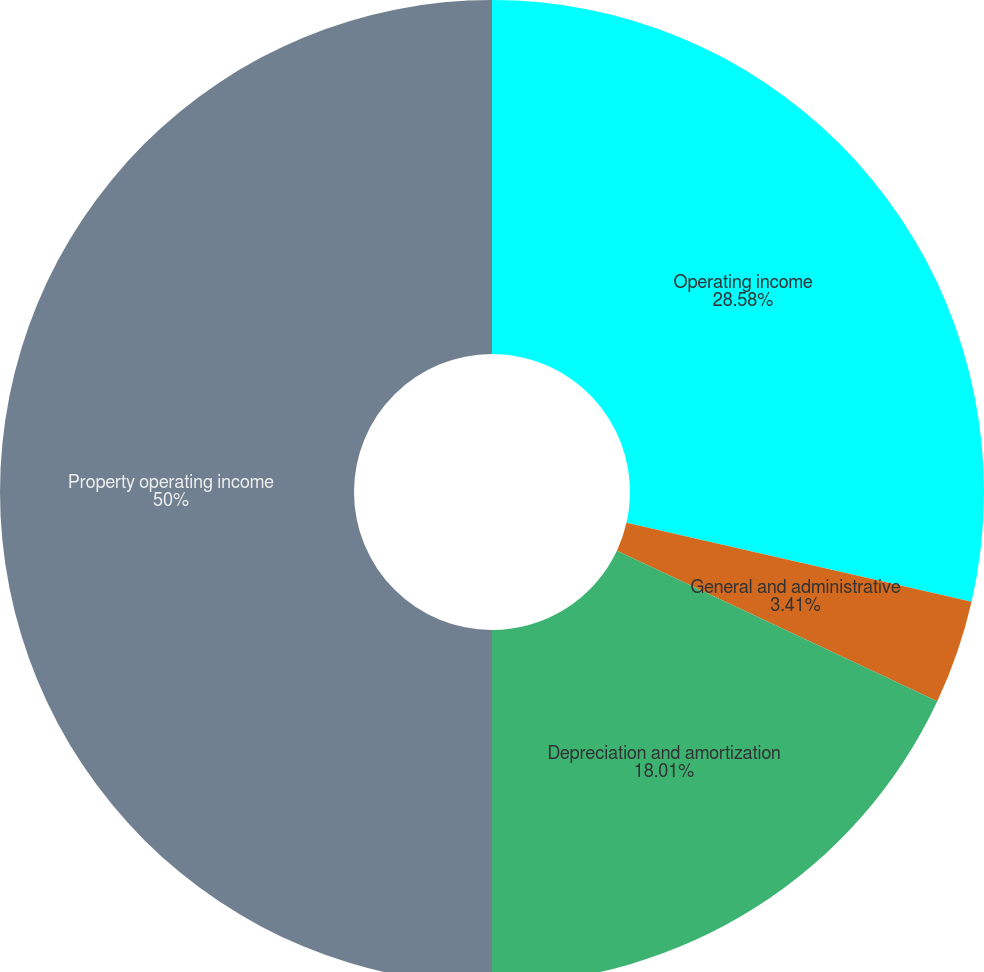Convert chart. <chart><loc_0><loc_0><loc_500><loc_500><pie_chart><fcel>Operating income<fcel>General and administrative<fcel>Depreciation and amortization<fcel>Property operating income<nl><fcel>28.58%<fcel>3.41%<fcel>18.01%<fcel>50.0%<nl></chart> 